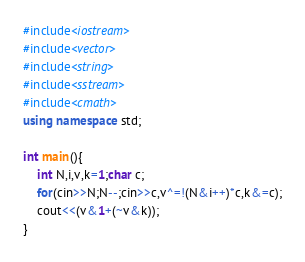Convert code to text. <code><loc_0><loc_0><loc_500><loc_500><_C++_>#include<iostream>
#include<vector>
#include<string>
#include<sstream>
#include<cmath>
using namespace std;

int main(){
    int N,i,v,k=1;char c;
    for(cin>>N;N--;cin>>c,v^=!(N&i++)*c,k&=c);
    cout<<(v&1+(~v&k));
}


</code> 